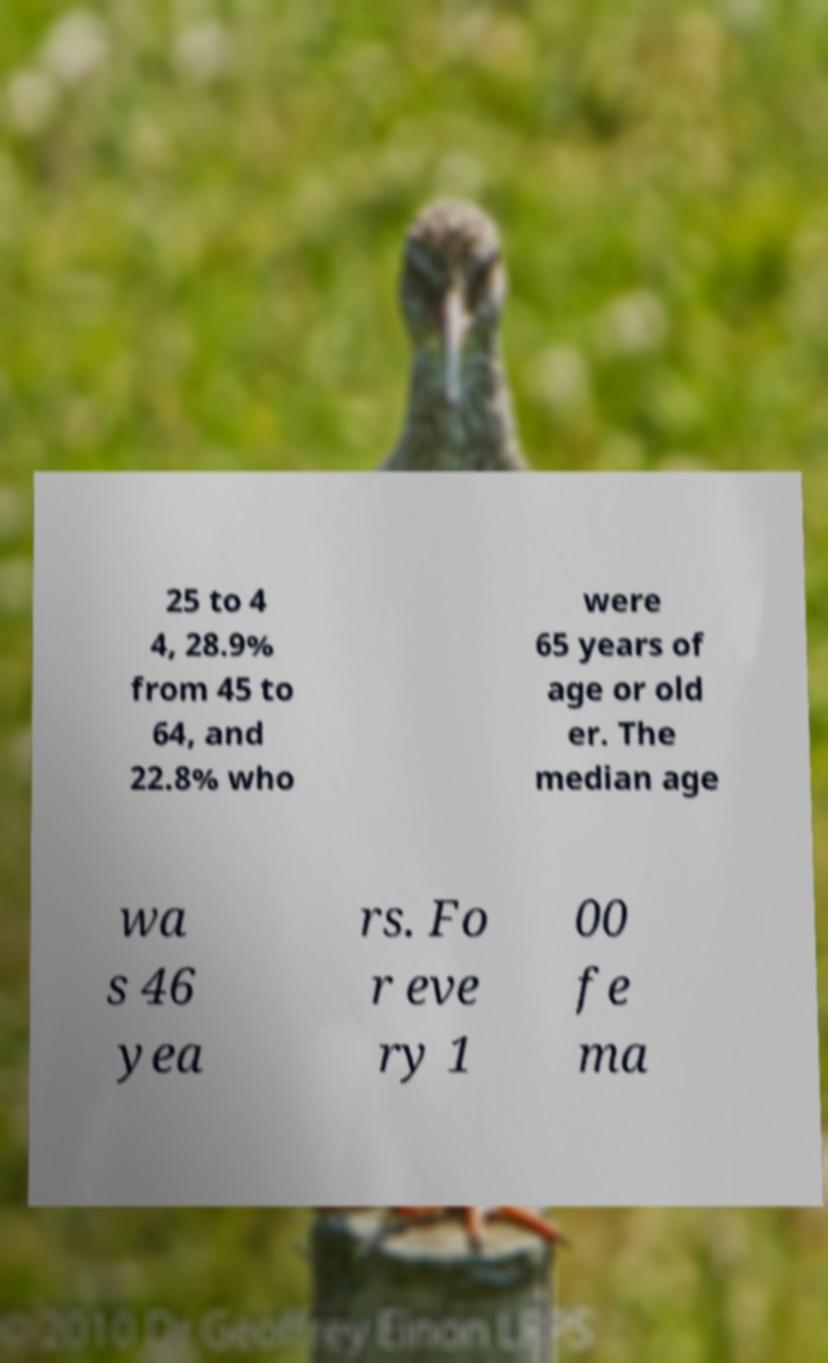For documentation purposes, I need the text within this image transcribed. Could you provide that? 25 to 4 4, 28.9% from 45 to 64, and 22.8% who were 65 years of age or old er. The median age wa s 46 yea rs. Fo r eve ry 1 00 fe ma 